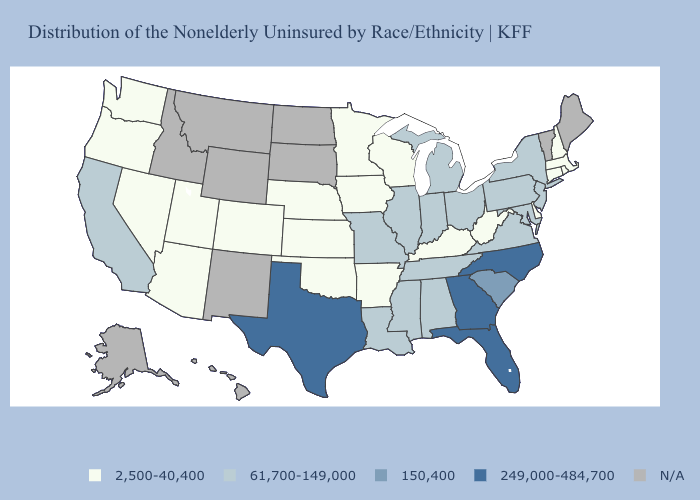Which states hav the highest value in the Northeast?
Be succinct. New Jersey, New York, Pennsylvania. What is the value of Texas?
Be succinct. 249,000-484,700. Among the states that border Massachusetts , does New York have the lowest value?
Concise answer only. No. What is the value of Wisconsin?
Answer briefly. 2,500-40,400. What is the value of Wisconsin?
Answer briefly. 2,500-40,400. Name the states that have a value in the range N/A?
Quick response, please. Alaska, Hawaii, Idaho, Maine, Montana, New Mexico, North Dakota, South Dakota, Vermont, Wyoming. Name the states that have a value in the range 2,500-40,400?
Concise answer only. Arizona, Arkansas, Colorado, Connecticut, Delaware, Iowa, Kansas, Kentucky, Massachusetts, Minnesota, Nebraska, Nevada, New Hampshire, Oklahoma, Oregon, Rhode Island, Utah, Washington, West Virginia, Wisconsin. What is the highest value in the USA?
Quick response, please. 249,000-484,700. Name the states that have a value in the range 2,500-40,400?
Write a very short answer. Arizona, Arkansas, Colorado, Connecticut, Delaware, Iowa, Kansas, Kentucky, Massachusetts, Minnesota, Nebraska, Nevada, New Hampshire, Oklahoma, Oregon, Rhode Island, Utah, Washington, West Virginia, Wisconsin. What is the value of Iowa?
Be succinct. 2,500-40,400. What is the highest value in states that border Idaho?
Answer briefly. 2,500-40,400. Which states have the highest value in the USA?
Short answer required. Florida, Georgia, North Carolina, Texas. Which states have the lowest value in the USA?
Write a very short answer. Arizona, Arkansas, Colorado, Connecticut, Delaware, Iowa, Kansas, Kentucky, Massachusetts, Minnesota, Nebraska, Nevada, New Hampshire, Oklahoma, Oregon, Rhode Island, Utah, Washington, West Virginia, Wisconsin. 